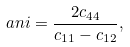Convert formula to latex. <formula><loc_0><loc_0><loc_500><loc_500>\ a n i = \frac { 2 c _ { 4 4 } } { c _ { 1 1 } - c _ { 1 2 } } ,</formula> 